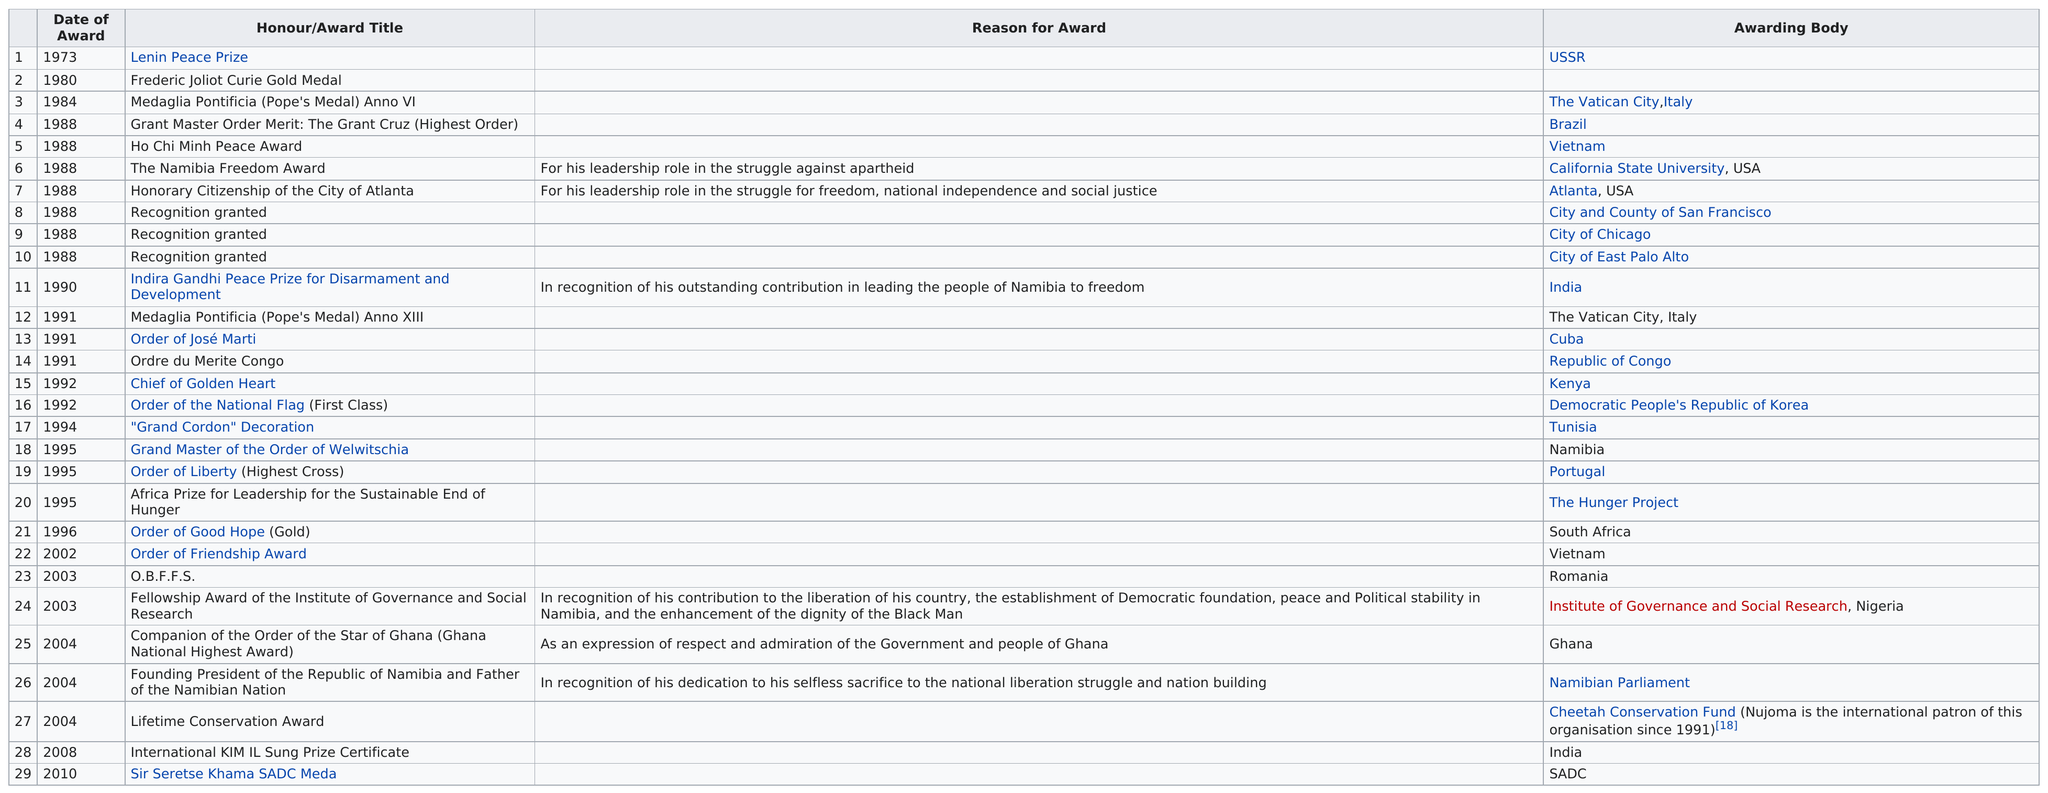Highlight a few significant elements in this photo. To date, a total of 29 awards and honors have been received. Before the Medaglia Pontificia Anno XIII was awarded, Indira Gandhi Peace Prize for Disarmament and Development was won. The number of times 'recognition granted' was the received award was 3. Nujoma has won a total of 29 awards. Nujoma has recently won the SADC Medal awarded by Sir Seretse Khama. 